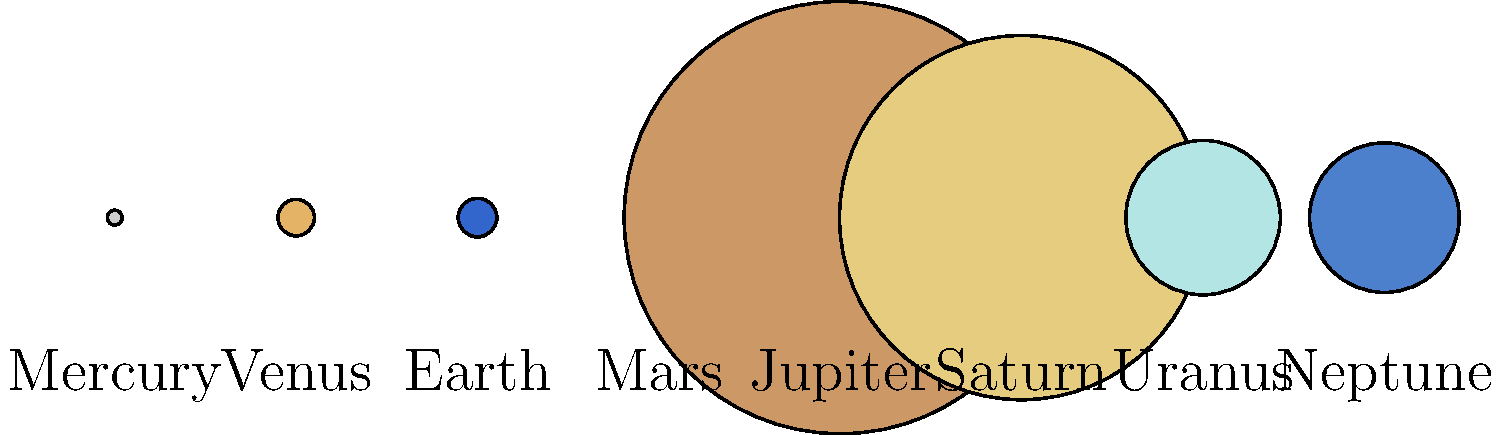As a motion graphic artist, you're tasked with creating an animation showcasing the relative sizes of planets in our solar system. Which planet should you use as the primary scale reference to ensure the most dramatic visual contrast between the largest and smallest planets? To answer this question, we need to consider the relative sizes of the planets and their visual impact:

1. Analyze the sizes provided in the graphic:
   Mercury: 4.9, Venus: 12.1, Earth: 12.8, Mars: 6.8
   Jupiter: 143, Saturn: 120.5, Uranus: 51.1, Neptune: 49.5

2. Identify the largest and smallest planets:
   Largest: Jupiter (143)
   Smallest: Mercury (4.9)

3. Calculate the ratio between the largest and smallest:
   Jupiter / Mercury = 143 / 4.9 ≈ 29.18

4. Consider the visual impact:
   Using Jupiter as the reference would make Mercury appear extremely small, creating a dramatic contrast.
   Using Mercury as the reference would make Jupiter appear enormous, also creating a striking visual.

5. Think about the storytelling aspect:
   In horror and mystery films, building tension often involves revealing something unexpectedly large.
   Starting with Mercury and progressively revealing larger planets would create a sense of growing scale and anticipation.

6. Consider the practical aspects of animation:
   Beginning with the smallest planet (Mercury) allows for a smooth progression in size, making the animation more fluid and engaging.

Given these factors, using Mercury as the primary scale reference would be most effective. It allows for a dramatic reveal of the gas giants, particularly Jupiter, which is approximately 29 times larger. This approach aligns well with storytelling techniques in horror and mystery genres, creating a sense of awe and potentially dread as the true scale of the larger planets is revealed.
Answer: Mercury 